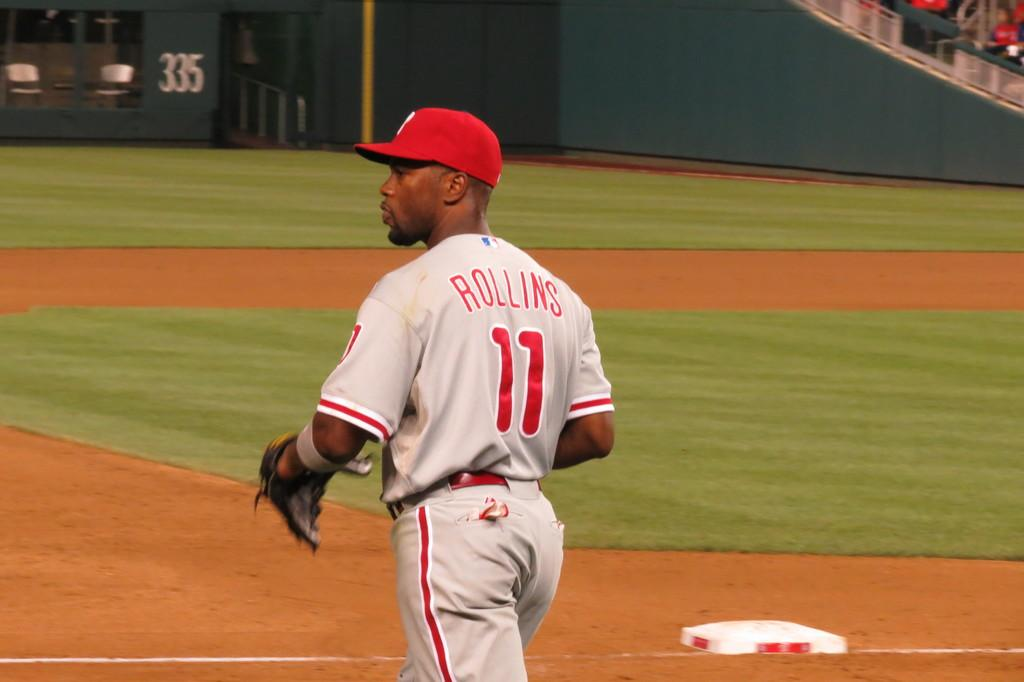<image>
Give a short and clear explanation of the subsequent image. Baseball player Rollins is number 11 and is walking on a baseball field. 